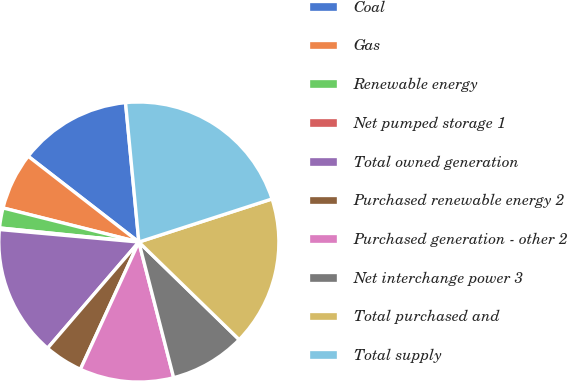Convert chart to OTSL. <chart><loc_0><loc_0><loc_500><loc_500><pie_chart><fcel>Coal<fcel>Gas<fcel>Renewable energy<fcel>Net pumped storage 1<fcel>Total owned generation<fcel>Purchased renewable energy 2<fcel>Purchased generation - other 2<fcel>Net interchange power 3<fcel>Total purchased and<fcel>Total supply<nl><fcel>12.99%<fcel>6.58%<fcel>2.31%<fcel>0.18%<fcel>15.12%<fcel>4.45%<fcel>10.85%<fcel>8.72%<fcel>17.26%<fcel>21.53%<nl></chart> 